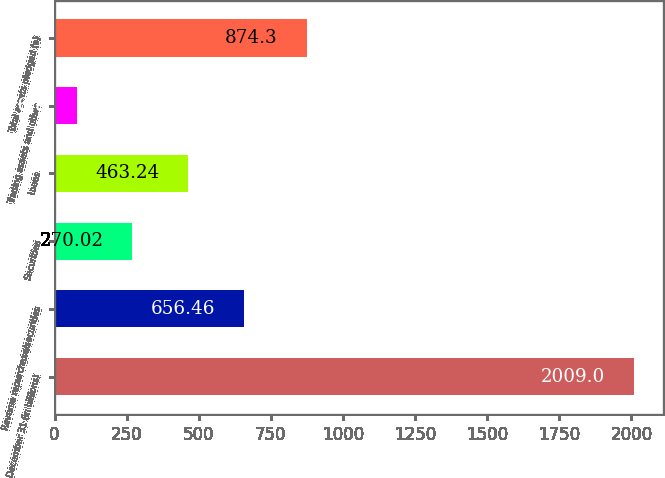Convert chart. <chart><loc_0><loc_0><loc_500><loc_500><bar_chart><fcel>December 31 (in billions)<fcel>Reverse repurchase/securities<fcel>Securities<fcel>Loans<fcel>Trading assets and other<fcel>Total assets pledged (a)<nl><fcel>2009<fcel>656.46<fcel>270.02<fcel>463.24<fcel>76.8<fcel>874.3<nl></chart> 